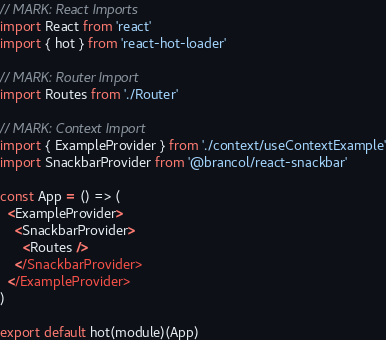Convert code to text. <code><loc_0><loc_0><loc_500><loc_500><_JavaScript_>// MARK: React Imports
import React from 'react'
import { hot } from 'react-hot-loader'

// MARK: Router Import
import Routes from './Router'

// MARK: Context Import
import { ExampleProvider } from './context/useContextExample'
import SnackbarProvider from '@brancol/react-snackbar'

const App = () => (
  <ExampleProvider>
    <SnackbarProvider>
      <Routes />
    </SnackbarProvider>
  </ExampleProvider>
)

export default hot(module)(App)
</code> 